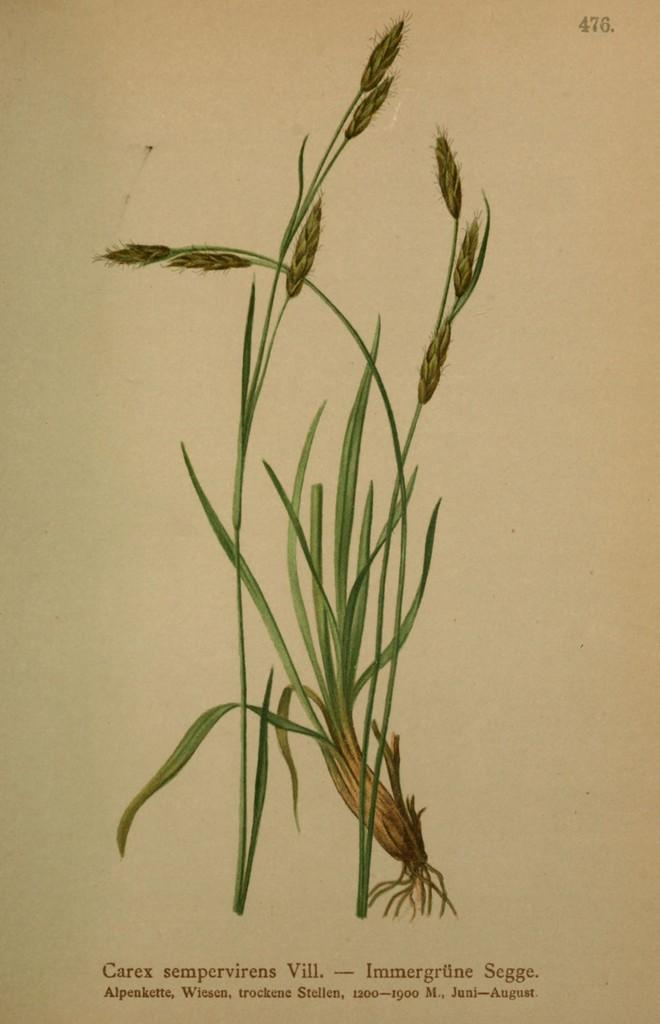What is the source of the image? The image is from a book page. What is depicted on the book page? There is an image of a plant on the page. What type of sheet is covering the plant in the image? There is no sheet covering the plant in the image; it is an image of a plant on a book page. 